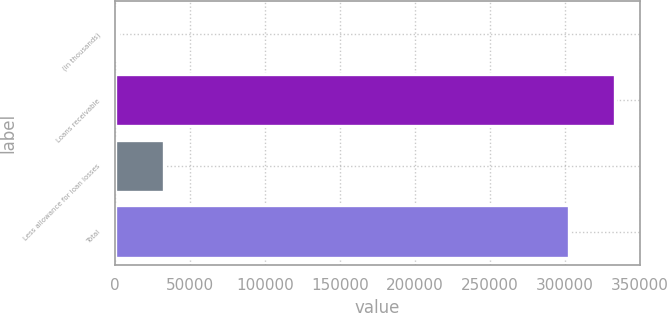Convert chart. <chart><loc_0><loc_0><loc_500><loc_500><bar_chart><fcel>(in thousands)<fcel>Loans receivable<fcel>Less allowance for loan losses<fcel>Total<nl><fcel>2009<fcel>333442<fcel>32701.8<fcel>302749<nl></chart> 